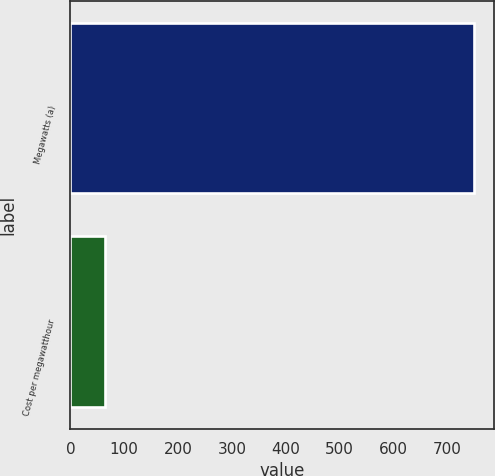Convert chart. <chart><loc_0><loc_0><loc_500><loc_500><bar_chart><fcel>Megawatts (a)<fcel>Cost per megawatthour<nl><fcel>750<fcel>64.75<nl></chart> 